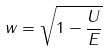<formula> <loc_0><loc_0><loc_500><loc_500>w = \sqrt { 1 - \frac { U } { E } }</formula> 